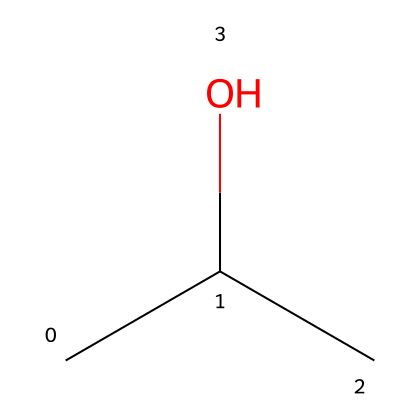How many carbon atoms are in isopropyl alcohol? The SMILES representation shows "CC(C)O", indicating three carbon atoms present in the chemical structure.
Answer: three What type of functional group is present in isopropyl alcohol? The "O" in the SMILES indicates the presence of an alcohol functional group, where the hydroxyl group (-OH) is attached to a carbon atom.
Answer: alcohol How many hydrogen atoms are in isopropyl alcohol? Each carbon typically forms four bonds; in this molecule, two carbon atoms are connected to two hydrogen atoms, while the other carbon is bonded to one hydroxyl group and one hydrogen atom, totaling seven hydrogen atoms.
Answer: seven What is the molecular formula of isopropyl alcohol? By combining the number of each type of atom: 3 carbons, 8 hydrogens, and 1 oxygen, the molecular formula is C3H8O.
Answer: C3H8O Is isopropyl alcohol a primary, secondary, or tertiary alcohol? The central carbon is bonded to two other carbon atoms, making this a secondary alcohol.
Answer: secondary What is the total number of bonds in isopropyl alcohol? In isopropyl alcohol, there are three carbon-carbon single bonds, seven carbon-hydrogen bonds, and one oxygen-hydrogen bond, leading to a total of eleven covalent bonds.
Answer: eleven 